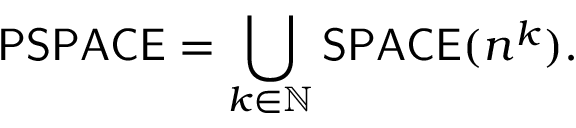Convert formula to latex. <formula><loc_0><loc_0><loc_500><loc_500>{ P S P A C E } = \bigcup _ { k \in \mathbb { N } } { S P A C E } ( n ^ { k } ) .</formula> 